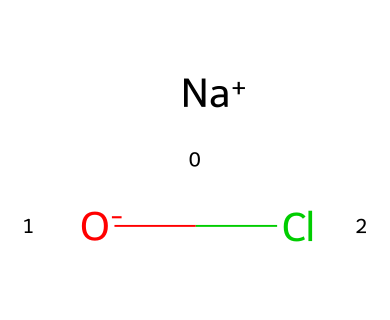What is the name of this chemical? The chemical represented by the SMILES notation [Na+].[O-]Cl is known as sodium hypochlorite. This is derived directly from the notation, which clearly indicates the presence of sodium, oxygen, and chlorine.
Answer: sodium hypochlorite How many atoms are present in this chemical? Analyzing the SMILES representation, we can count the distinct elements: there is one sodium atom, one oxygen atom, and one chlorine atom. Together, that totals three atoms in the molecule.
Answer: three What is the oxidation state of chlorine in this chemical? In sodium hypochlorite, chlorine is in an oxidation state of +1. This can be inferred from the oxidation states of sodium (+1) and oxygen (-2); since the compound is neutral, chlorine must balance this to total zero.
Answer: +1 How many bonds are present in the chemical structure? The structure includes one ionic bond between sodium and hypochlorite (OCl) and one covalent bond between oxygen and chlorine. Therefore, there are two distinct bonds present in the chemical structure.
Answer: two What type of chemical reaction can sodium hypochlorite undergo? Sodium hypochlorite is a strong oxidizer and can undergo oxidation-reduction (redox) reactions, specifically acting as an electron acceptor. This is indicated by its structure and the presence of reactive oxygen.
Answer: redox reactions What is the primary use of sodium hypochlorite in agriculture? Sodium hypochlorite is primarily used for water treatment in agriculture, particularly for disinfecting water for irrigation purposes. This is due to its strong oxidizing properties that kill pathogens and bacteria in water.
Answer: water treatment 